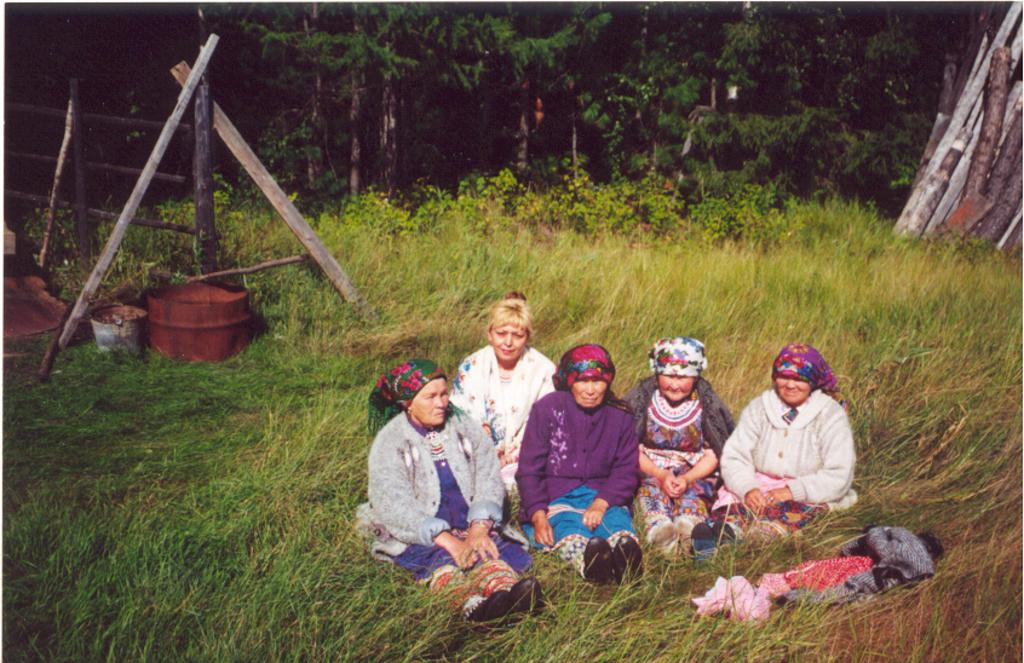What is the main subject of the image? The main subject of the image is a group of people. Where are the people in the image located? The people are sitting in the grass. What are the people wearing on their heads? The people are wearing headgear. What can be seen in the background of the image? There are trees visible in the image. What type of marble is being used for the game in the image? There is no game or marble present in the image; it features a group of people sitting in the grass wearing headgear. 